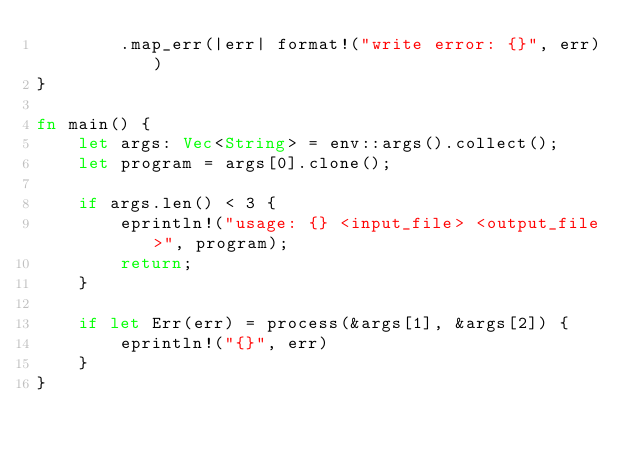Convert code to text. <code><loc_0><loc_0><loc_500><loc_500><_Rust_>        .map_err(|err| format!("write error: {}", err))
}

fn main() {
    let args: Vec<String> = env::args().collect();
    let program = args[0].clone();

    if args.len() < 3 {
        eprintln!("usage: {} <input_file> <output_file>", program);
        return;
    }

    if let Err(err) = process(&args[1], &args[2]) {
        eprintln!("{}", err)
    }
}
</code> 